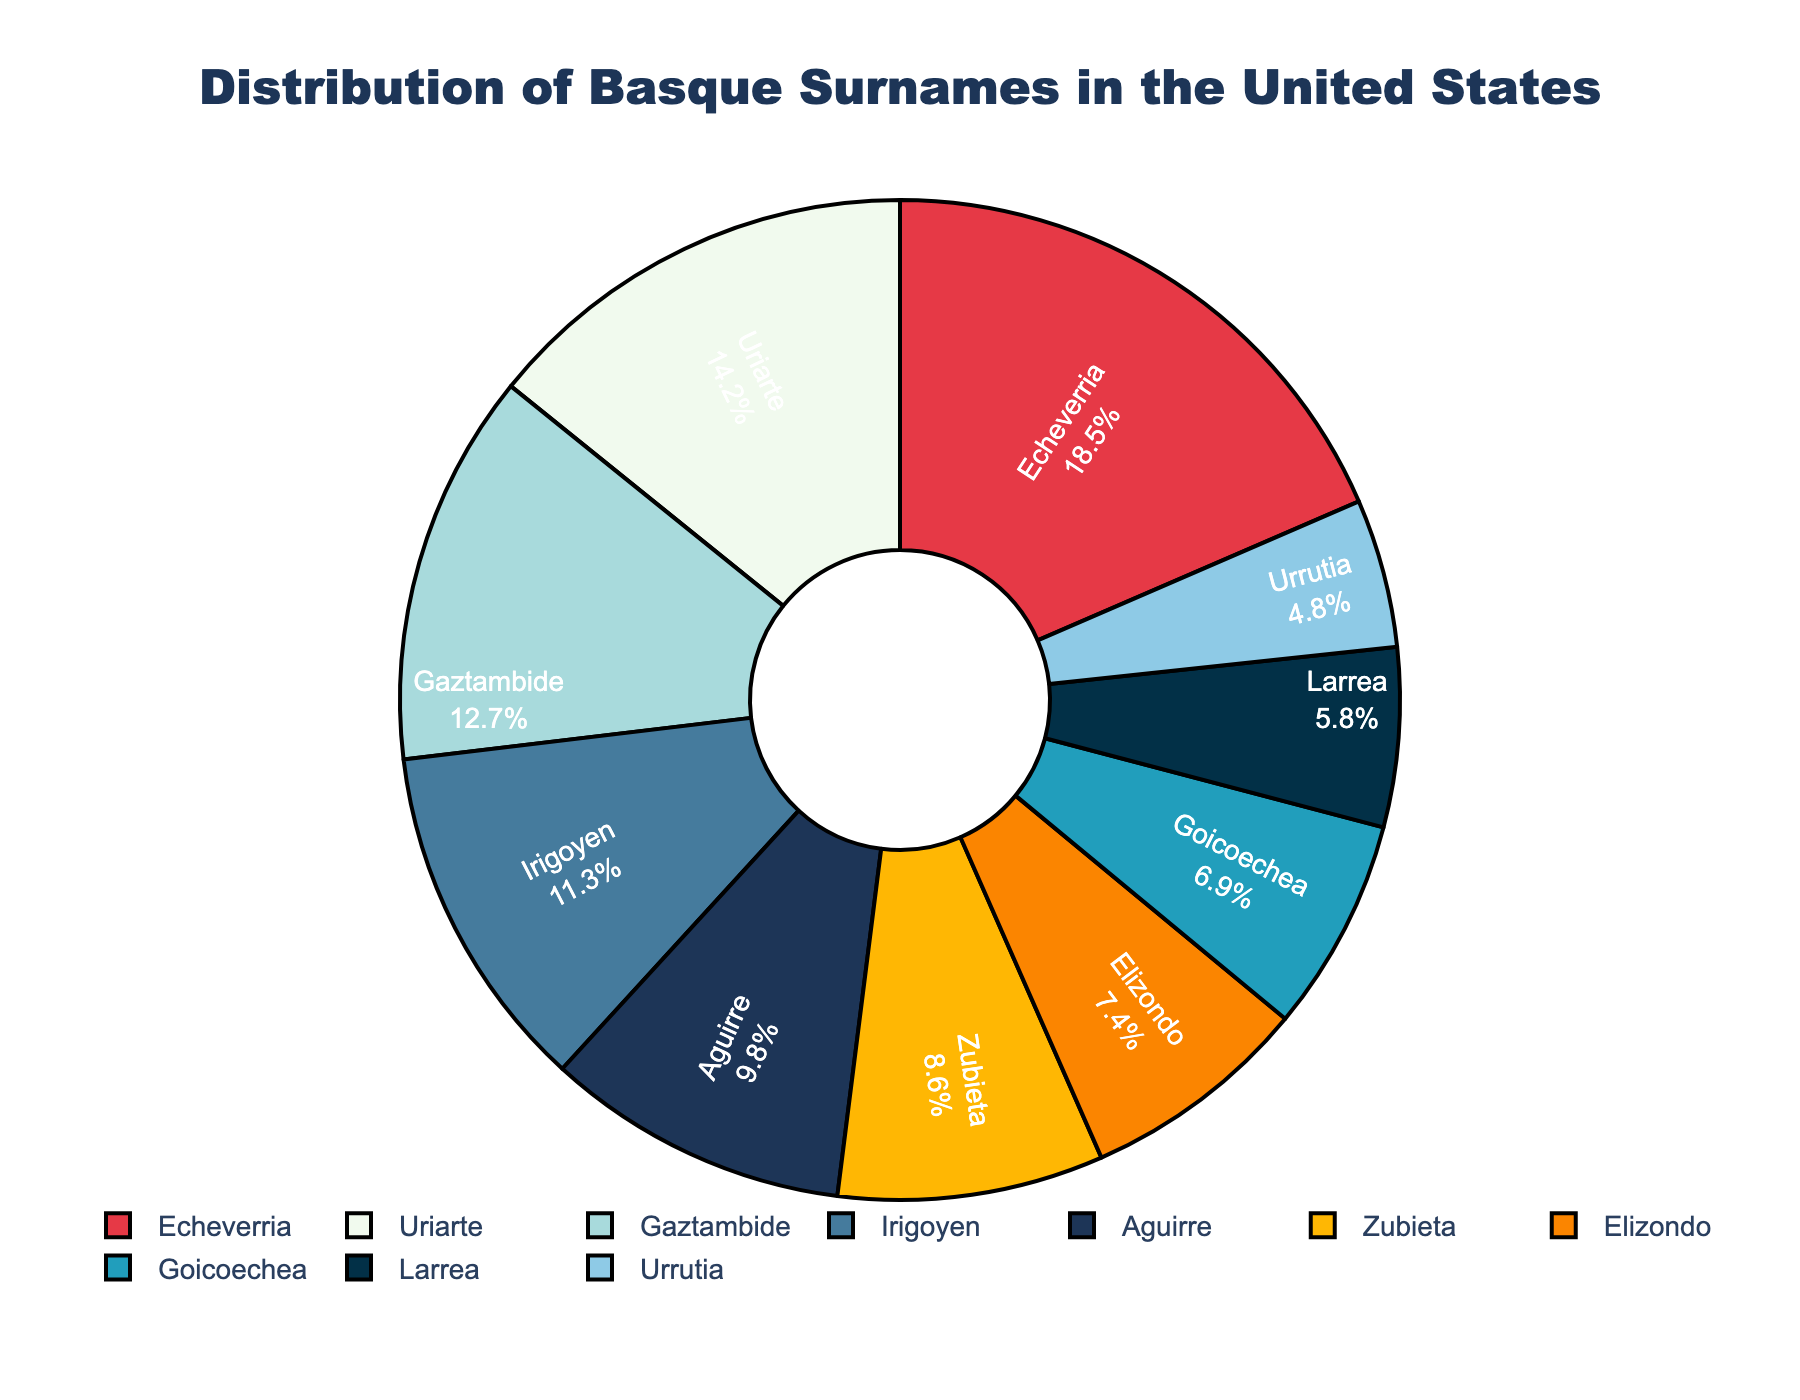What is the largest segment in the pie chart? The largest segment in the pie chart is represented by the surname with the highest percentage. Observing the chart, Echeverria has the largest segment with 18.5%.
Answer: Echeverria What two surnames together make up more than 30% of the distribution? To find which two surnames together exceed 30%, look for pairs whose combined percentages are more than 30. Echeverria (18.5%) and Uriarte (14.2%) together total 32.7%.
Answer: Echeverria and Uriarte Which surname is represented by a red segment? By checking the legend and the chart, the red segment corresponds to the surname with the specified color. The red segment represents Echeverria.
Answer: Echeverria How much larger is the percentage of Aguirre compared to Urrutia? To find the difference, subtract Urrutia's percentage (4.8%) from Aguirre's (9.8%). \(9.8\% - 4.8\% = 5\%\).
Answer: 5% What is the combined percentage of the three smallest segments? Identify and sum the percentages of the three smallest segments: Urrutia (4.8%), Larrea (5.8%), and Goicoechea (6.9%). \(4.8\% + 5.8\% + 6.9\% = 17.5\%\).
Answer: 17.5% Which surname is represented by the blue segment? Examining the legend and the chart, the blue segment represents Goicoechea.
Answer: Goicoechea Which segment is visually closest in size to Irigoyen? Comparing the sizes visually and using the legend, Aguirre (9.8%) and Irigoyen (11.3%) have similar sizes.
Answer: Aguirre Is the percentage of Elizondo greater than Gaztambide? Comparing percentages: Elizondo (7.4%) is less than Gaztambide (12.7%).
Answer: No Which two surnames together account for less than 15% of the distribution? Adding pairs to find which sum less than 15%: Urrutia (4.8%) and Larrea (5.8%) together are 10.6%.
Answer: Urrutia and Larrea 